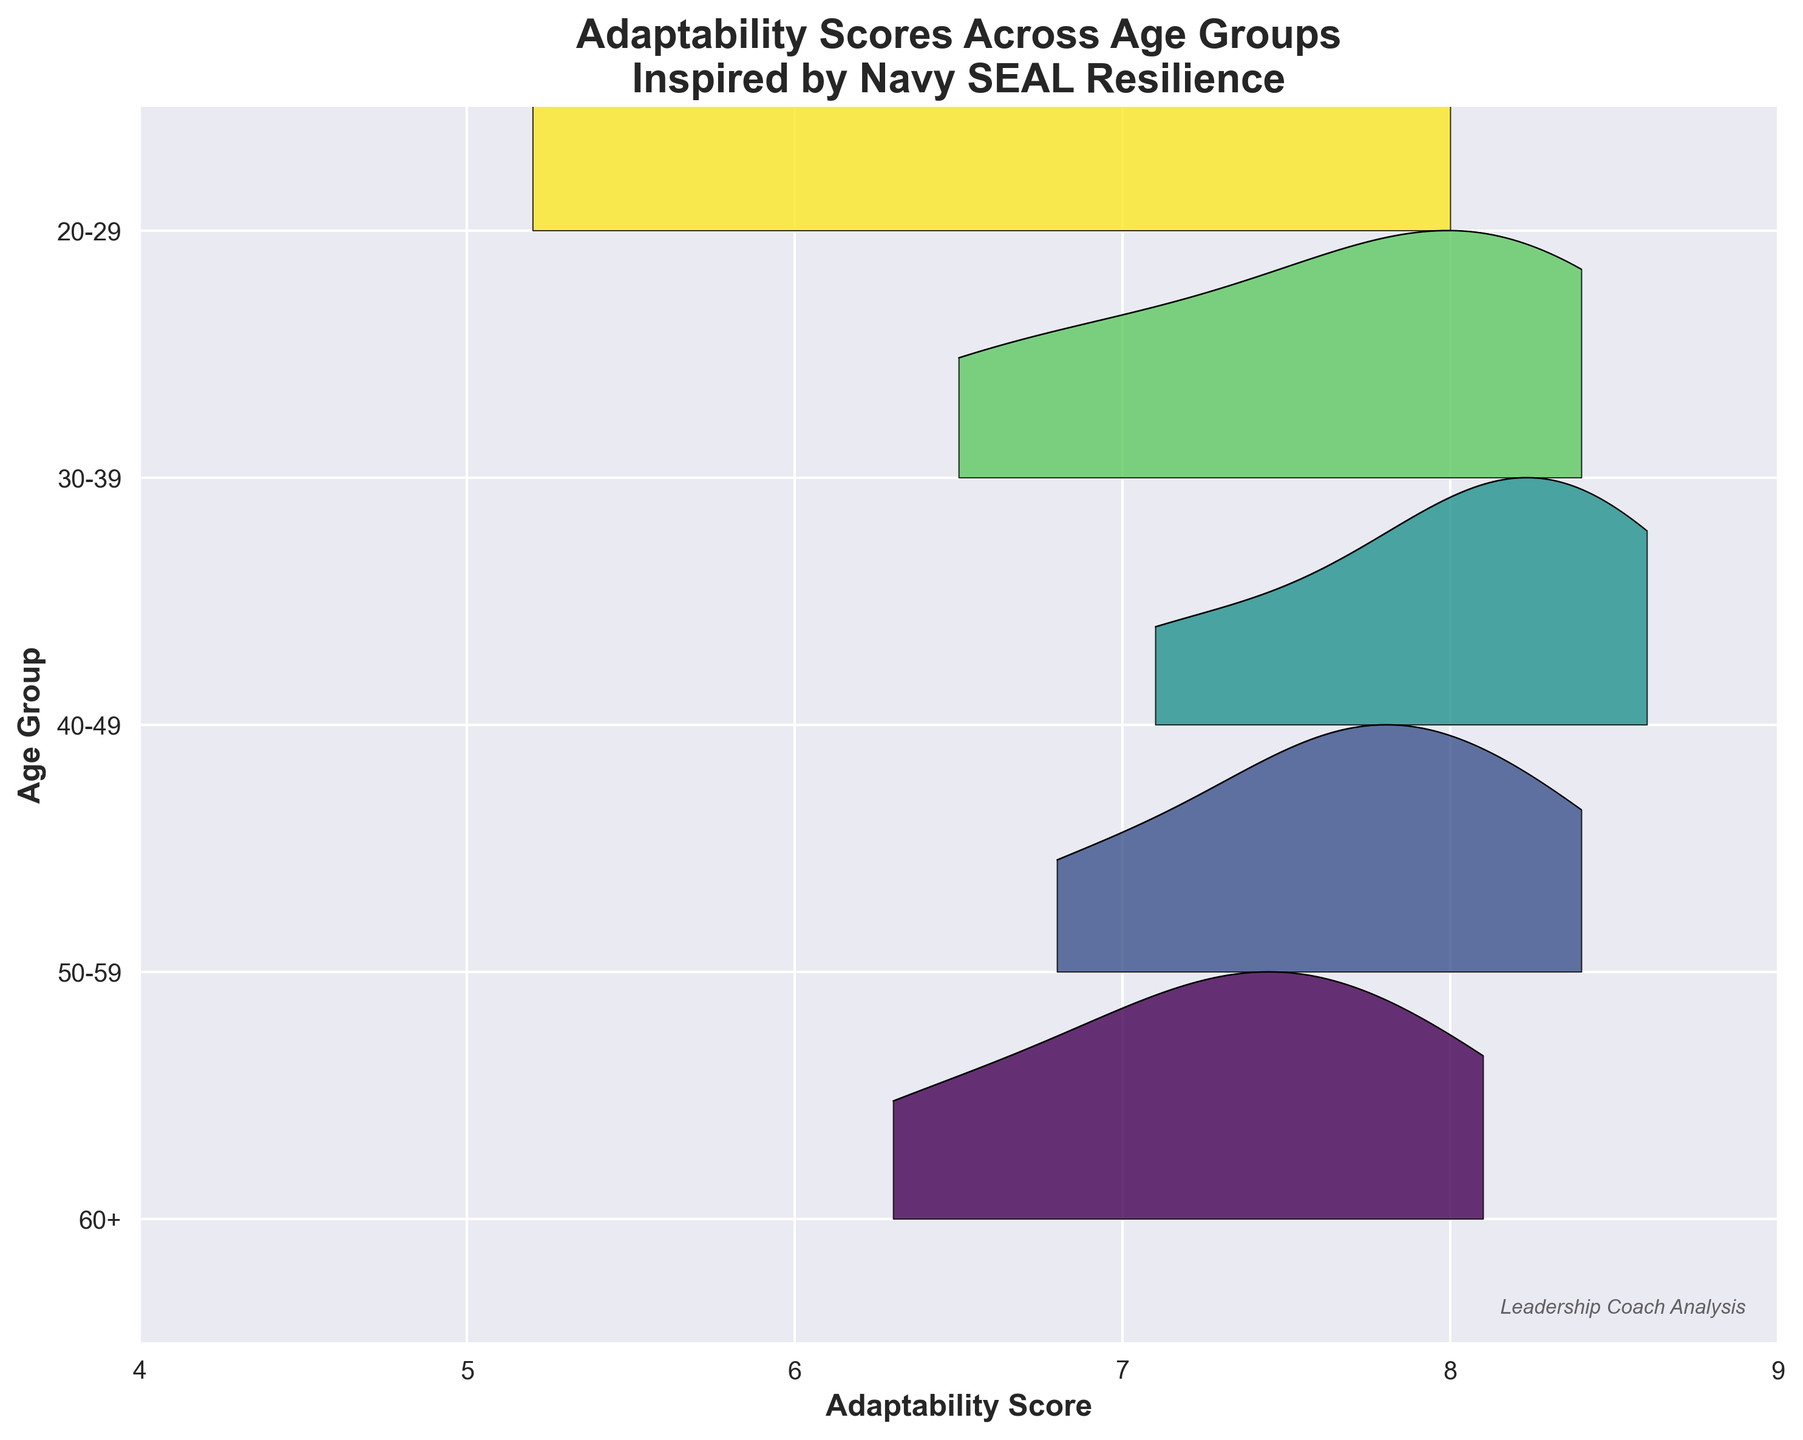Which age group has the highest median Adaptability Score? To find the median Adaptability Score, look for the central tendency in each age group. Observing the distribution centers in the plot, the 40-49 group has the highest median score.
Answer: 40-49 What is the range of Adaptability Scores for the 30-39 age group? The plot for the 30-39 age group spans from roughly 6 to 9. Thus, the range is the difference between these two values.
Answer: 6 to 9 Which age group shows the widest spread in Adaptability Scores? The spread of scores for each age group can be compared by observing the width of the distributions in the plot. The 20-29 age group has the widest spread.
Answer: 20-29 Which age group has the highest peak in Adaptability Scores? Examining the height of the peaks in the ridgeline plot, the 40-49 age group has the highest peak, indicating the most concentrated scores around a central value.
Answer: 40-49 Are there any age groups that have overlapping ranges of Adaptability Scores? Some of the distributions overlap. For instance, the core ranges of the 30-39, 40-49, and 50-59 age groups overlap around scores between 7 and 8.5.
Answer: Yes Do older age groups (60+) have higher adaptability than the youngest age group (20-29)? Comparing the distribution centers and peaks, the youngest group (20-29) has higher scores overall compared to the 60+ group. Thus, younger professionals exhibit higher adaptability scores than older ones.
Answer: No How many age groups are represented in the plot? By counting the distinct y-axis labels, we identify five unique age groups displayed on the plot.
Answer: 5 Which age group has the lowest adaptability score? Observing the leftmost extent of the distributions, the lowest score of around 5 appears in the 20-29 age group.
Answer: 20-29 